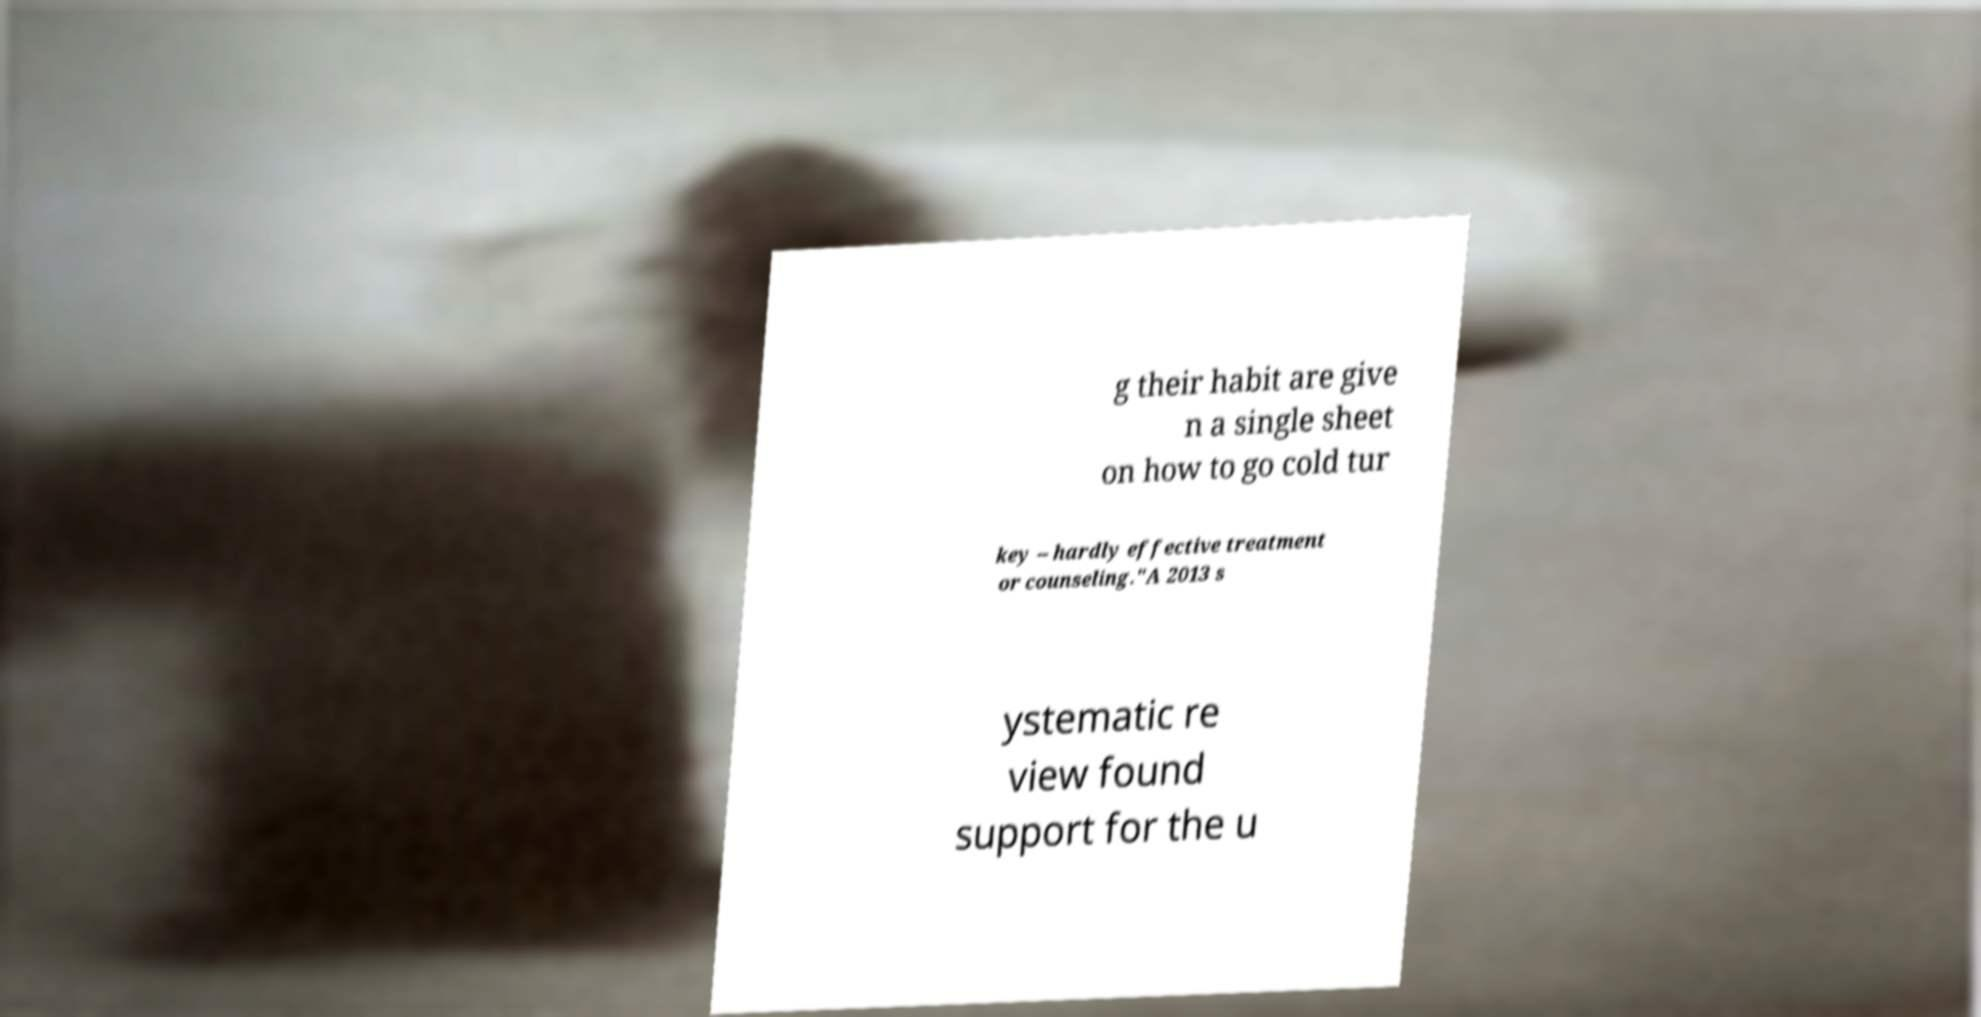Could you extract and type out the text from this image? g their habit are give n a single sheet on how to go cold tur key -- hardly effective treatment or counseling."A 2013 s ystematic re view found support for the u 